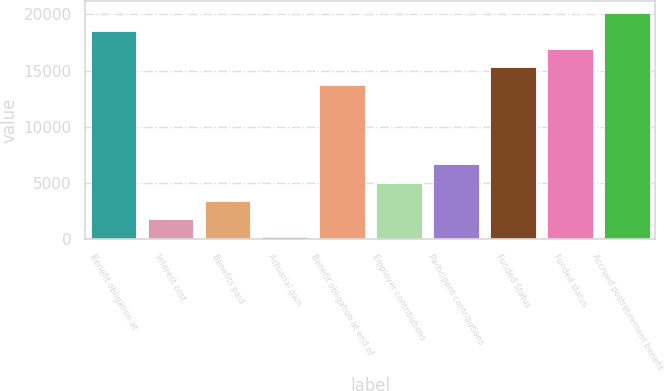Convert chart. <chart><loc_0><loc_0><loc_500><loc_500><bar_chart><fcel>Benefit obligation at<fcel>Interest cost<fcel>Benefits paid<fcel>Actuarial gain<fcel>Benefit obligation at end of<fcel>Employer contributions<fcel>Participant contributions<fcel>Funded Status<fcel>Funded status<fcel>Accrued postretirement benefit<nl><fcel>18544<fcel>1814<fcel>3425<fcel>203<fcel>13711<fcel>5036<fcel>6647<fcel>15322<fcel>16933<fcel>20155<nl></chart> 